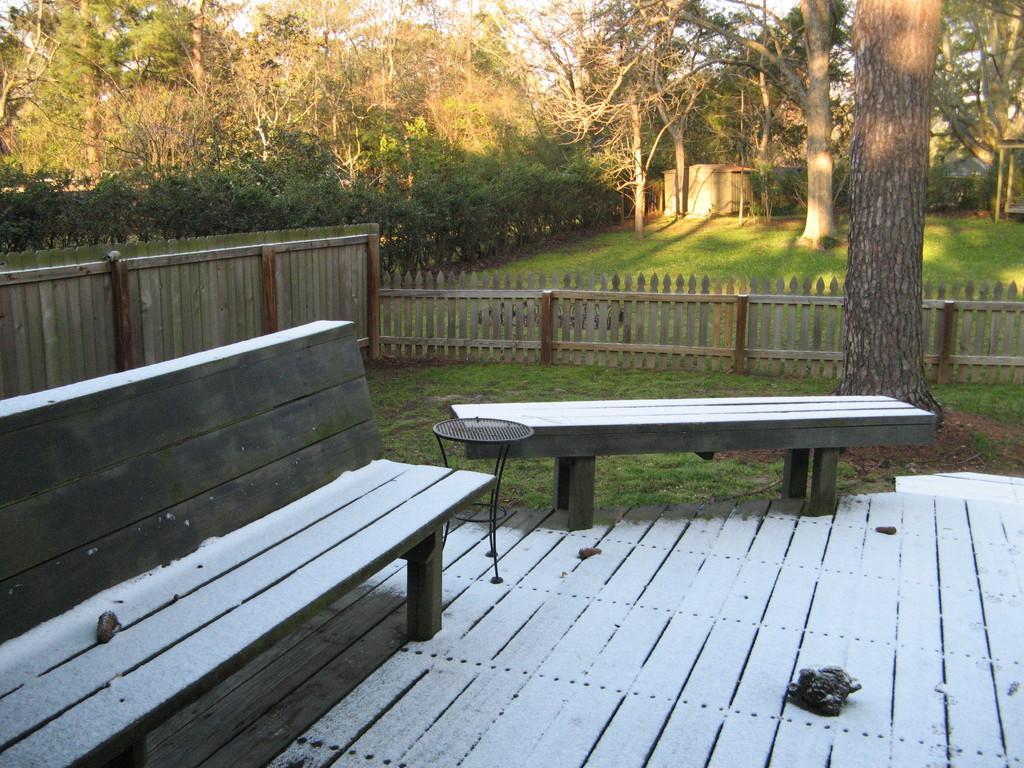Describe this image in one or two sentences. In this image I can see two benches. In the background I can see few trees in green color and the sky is in white color. 